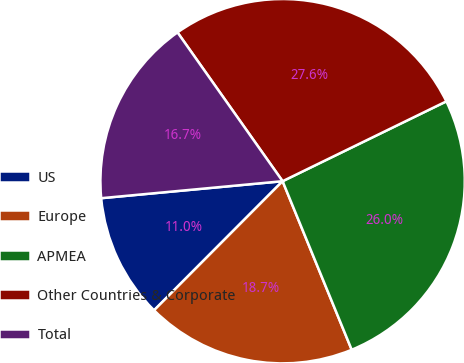<chart> <loc_0><loc_0><loc_500><loc_500><pie_chart><fcel>US<fcel>Europe<fcel>APMEA<fcel>Other Countries & Corporate<fcel>Total<nl><fcel>11.05%<fcel>18.66%<fcel>26.03%<fcel>27.57%<fcel>16.7%<nl></chart> 